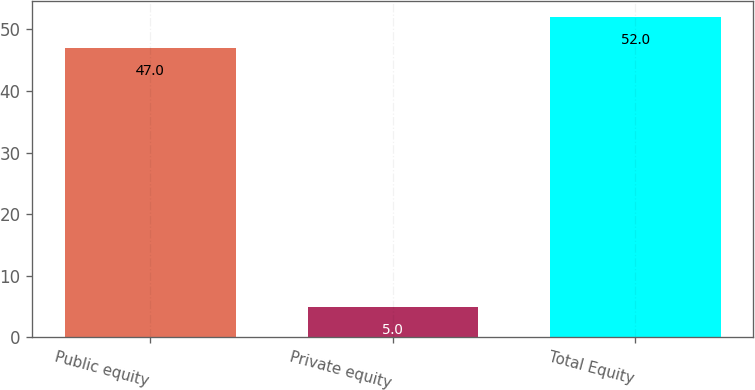<chart> <loc_0><loc_0><loc_500><loc_500><bar_chart><fcel>Public equity<fcel>Private equity<fcel>Total Equity<nl><fcel>47<fcel>5<fcel>52<nl></chart> 